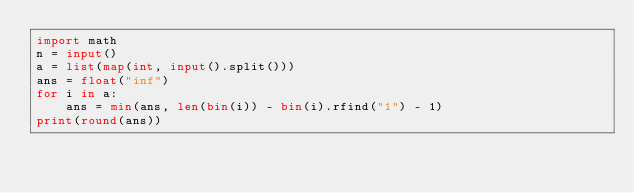<code> <loc_0><loc_0><loc_500><loc_500><_Python_>import math
n = input()
a = list(map(int, input().split()))
ans = float("inf")
for i in a:
    ans = min(ans, len(bin(i)) - bin(i).rfind("1") - 1)
print(round(ans))</code> 